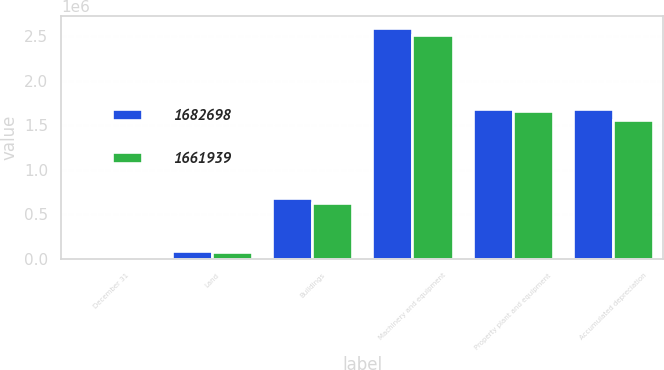Convert chart. <chart><loc_0><loc_0><loc_500><loc_500><stacked_bar_chart><ecel><fcel>December 31<fcel>Land<fcel>Buildings<fcel>Machinery and equipment<fcel>Property plant and equipment<fcel>Accumulated depreciation<nl><fcel>1.6827e+06<fcel>2004<fcel>84563<fcel>688642<fcel>2.596e+06<fcel>1.6827e+06<fcel>1.6865e+06<nl><fcel>1.66194e+06<fcel>2003<fcel>78744<fcel>633362<fcel>2.51492e+06<fcel>1.66194e+06<fcel>1.56508e+06<nl></chart> 